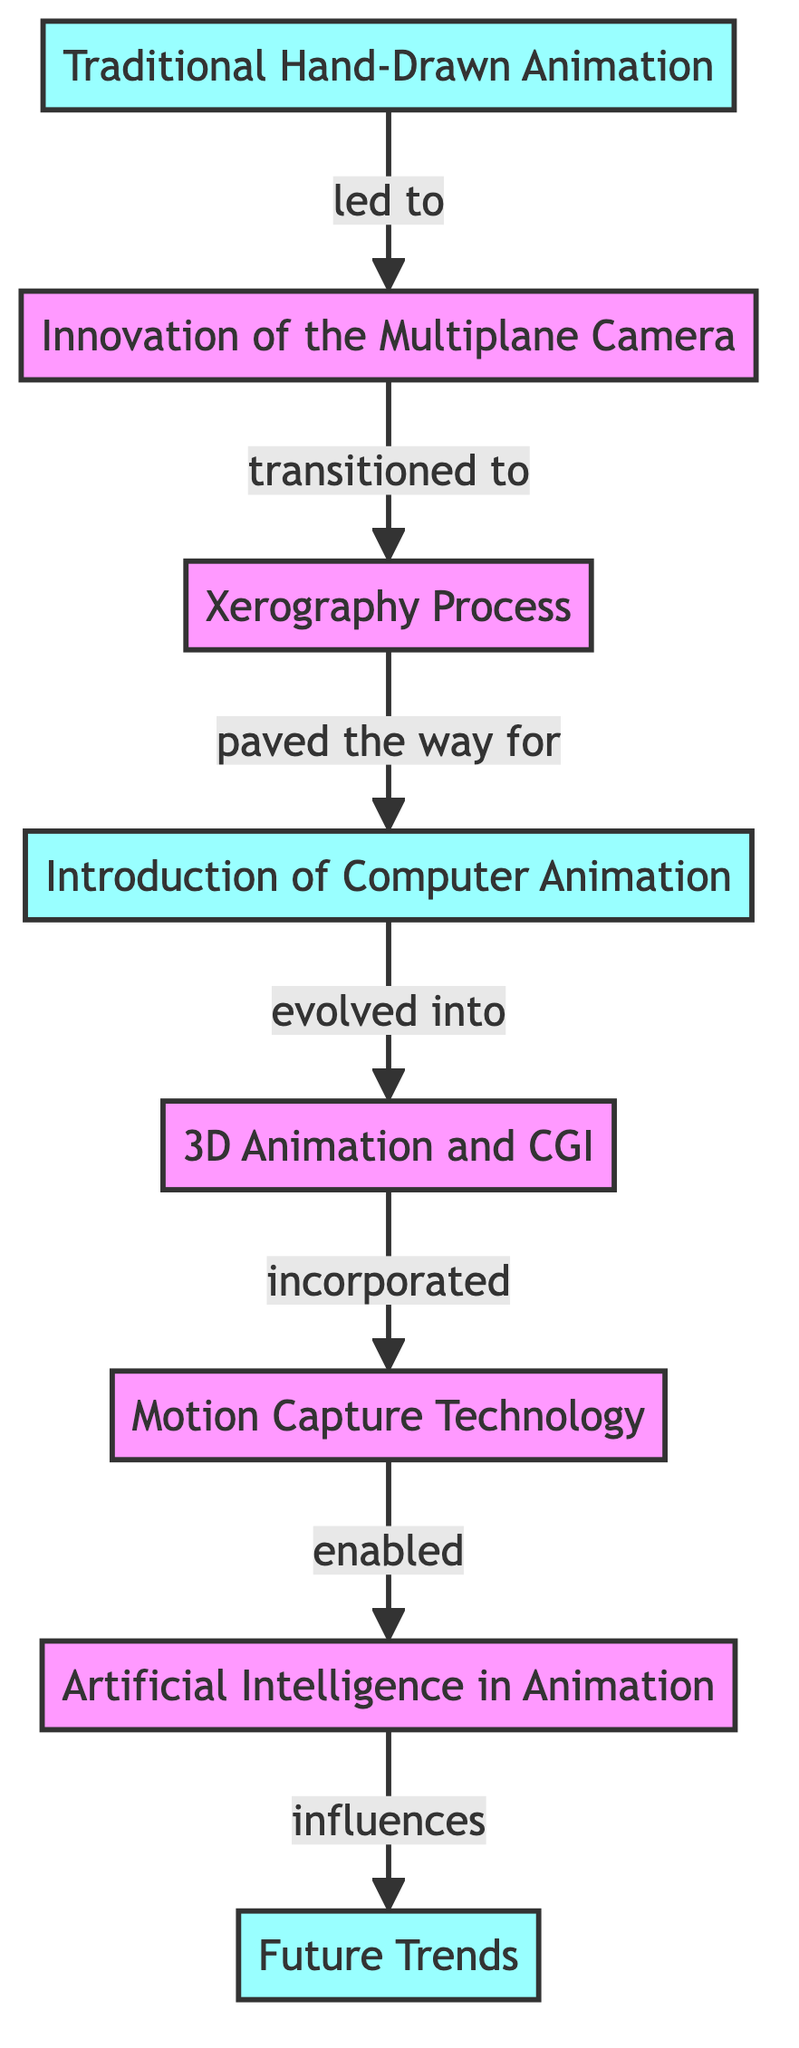What is the first technique in the evolution of Disney animation according to the diagram? The diagram lists "Traditional Hand-Drawn Animation" as the first technique in the sequence of advancements.
Answer: Traditional Hand-Drawn Animation Which technique directly followed the innovation of the multiplane camera? According to the diagram, after the "Innovation of the Multiplane Camera," the next technique is the "Xerography Process."
Answer: Xerography Process How many techniques are listed in total in the diagram? The diagram contains eight nodes representing different techniques in Disney animation evolution, which indicates a total of eight techniques.
Answer: 8 What does the motion capture technology enable in the context of Disney animations? The diagram indicates that motion capture technology "enabled" the use of "Artificial Intelligence in Animation."
Answer: Artificial Intelligence in Animation Identify the last technique mentioned in the diagram. The diagram shows "Future Trends" as the last technique listed in the sequence, completing the flow of development.
Answer: Future Trends What relationship is described between 3D animation and CGI? The diagram states that "3D Animation and CGI" is described as having "incorporated" motion capture technology, showing their interconnectedness in the animation evolution.
Answer: incorporated What was the progression of techniques from the introduction of computer animation? Following the "Introduction of Computer Animation," the technique that "evolved" is "3D Animation and CGI," creating a clear pathway of progression.
Answer: 3D Animation and CGI How does the diagram depict the transition from traditional to advanced animation? The diagram visually represents a timeline, starting from "Traditional Hand-Drawn Animation" and showing sequential advancements leading up to "Artificial Intelligence in Animation," illustrating a clear evolutionary pathway in animation techniques.
Answer: evolutionary pathway What type of diagram is used to present the evolution of animation techniques? The diagram is a flowchart, which effectively demonstrates the progression and relationships among various Disney animation techniques over time.
Answer: flowchart 